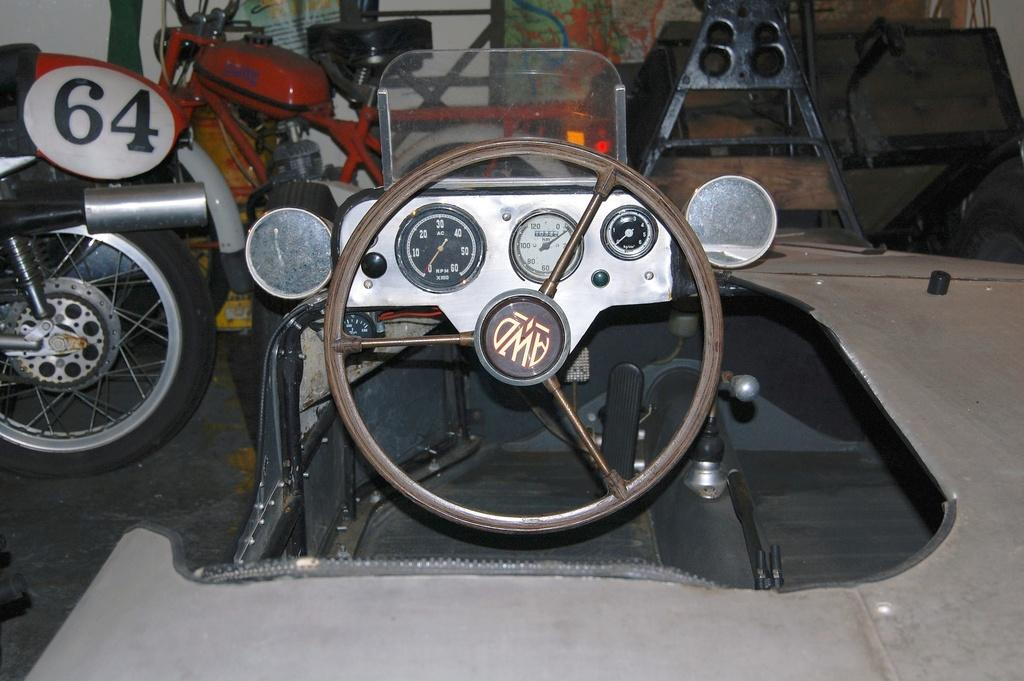What types of vehicles can be seen in the image? There are vehicles in the image, but the specific types cannot be determined from the provided facts. What is located in the top right corner of the image? There are objects in the top right corner of the image, but their nature cannot be determined from the provided facts. What can be seen beneath the vehicles in the image? The ground is visible in the image. What type of structure is present in the image? There is a wall in the image. What type of current is flowing through the steel wall in the image? There is no mention of a steel wall or any current in the image; the facts only mention vehicles, objects in the top right corner, the ground, and a wall. 